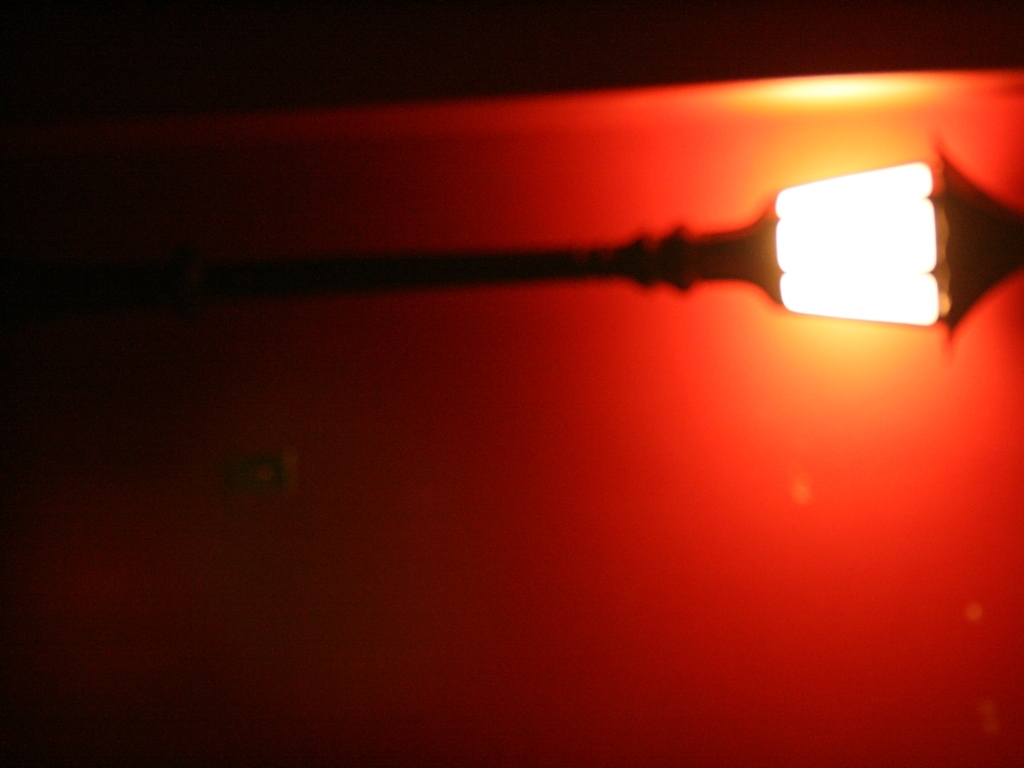What possible applications or themes can this image represent? This image can be used to represent various themes, including loneliness, warmth in darkness, or the idea of finding guidance or direction in uncertain situations, symbolized by the single light source. 